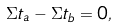Convert formula to latex. <formula><loc_0><loc_0><loc_500><loc_500>\Sigma t _ { a } - \Sigma t _ { b } = 0 ,</formula> 